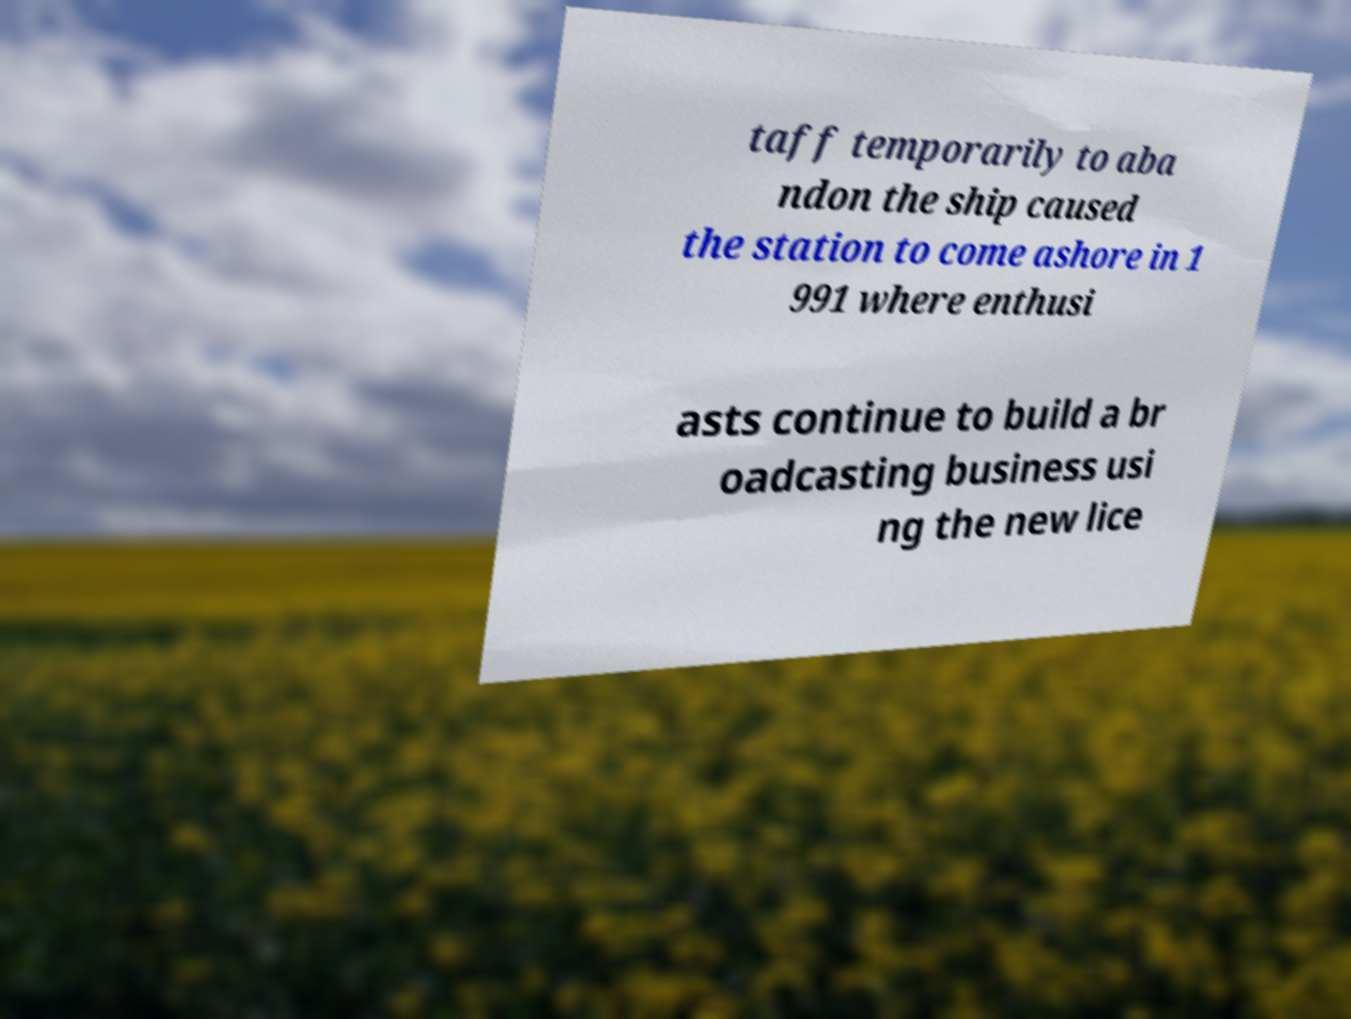Please read and relay the text visible in this image. What does it say? taff temporarily to aba ndon the ship caused the station to come ashore in 1 991 where enthusi asts continue to build a br oadcasting business usi ng the new lice 